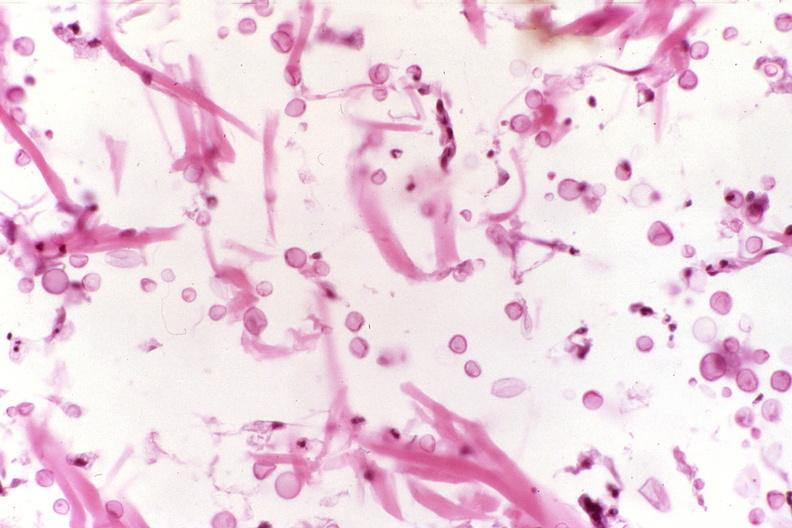does amyloid angiopathy r. endocrine show cryptococcal dematitis?
Answer the question using a single word or phrase. No 